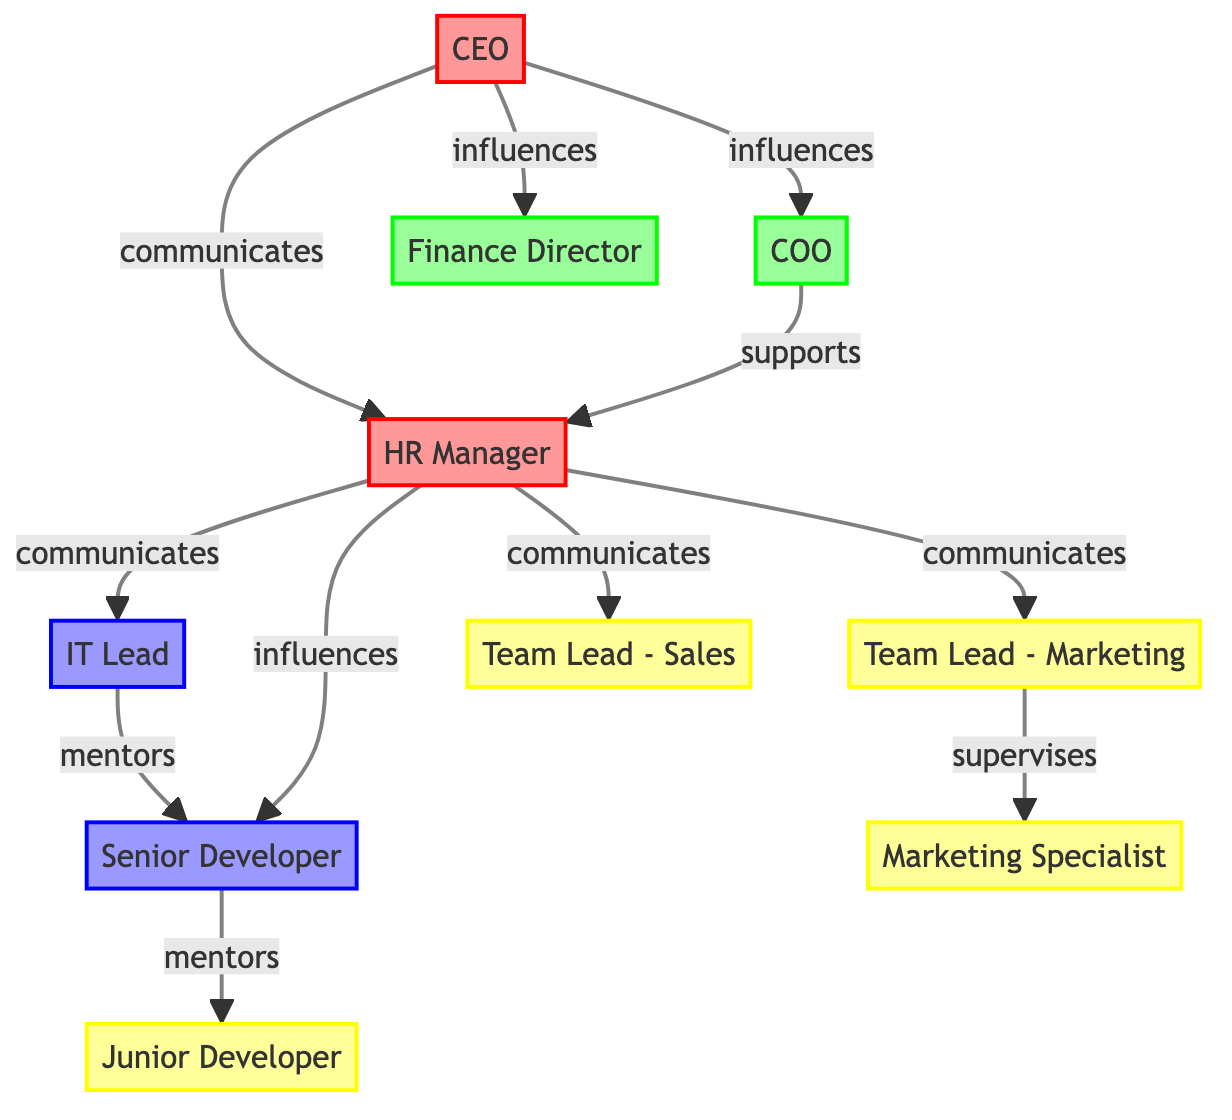What is the role of the CEO in the diagram? The diagram indicates that the CEO has the role of "change_agent," as specified by the role attribute in the node information for the CEO.
Answer: change_agent How many individuals are classified as bystanders? By examining the nodes section of the diagram, there are three individuals labeled as bystanders: Team Lead - Marketing, Team Lead - Sales, and Junior Developer. Therefore, the total is three.
Answer: 3 Which node does the HR Manager communicate with? The edges indicate that the HR Manager communicates with IT Lead, Team Lead - Marketing, Team Lead - Sales, and influences Senior Developer, matching the paths shown in the diagram. Therefore, the answer is "IT Lead, Team Lead - Marketing, Team Lead - Sales."
Answer: IT Lead, Team Lead - Marketing, Team Lead - Sales What is the relationship between the CEO and Finance Director? According to the edges in the diagram, the relationship is characterized as "influences," indicating that the CEO has a direct influence on the Finance Director.
Answer: influences Which role does the Employee 1 hold? Referring to the nodes, Employee 1 is labeled as "Senior Developer," and also is classified as a resistor, which is specified in the node's role property.
Answer: resistor How many total edges connect the nodes in the diagram? By counting the edges listed, there are ten connections between nodes, showing how they interact with each other in the organizational change context.
Answer: 10 Which individual does IT Lead mentor? The edges indicate that the IT Lead has a mentoring relationship with Employee 1. According to the edges of the diagram, the mentoring direction flows from IT Lead to Employee 1, thus the answer is "Employee 1."
Answer: Employee 1 What type of influence does COO have over HR Manager? The edge from COO to HR Manager is labeled "supports," indicating a supportive relationship rather than a direct influence in the typical sense.
Answer: supports Which change agent communicates with the CEO? The diagram specifies that the HR Manager communicates with the CEO, as indicated in the edges section showing direct communication from CEO to HR Manager.
Answer: HR Manager 